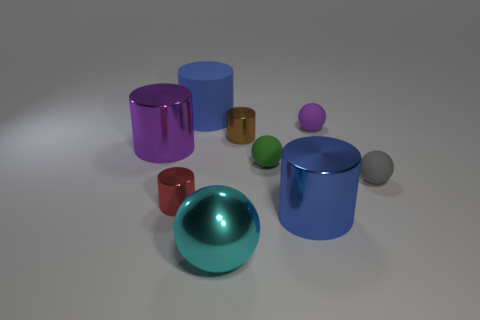Is there anything else of the same color as the big shiny ball?
Your answer should be compact. No. Is the material of the large blue thing right of the cyan thing the same as the small purple object?
Your response must be concise. No. What number of things are behind the large blue metal cylinder and right of the tiny brown object?
Ensure brevity in your answer.  3. How big is the blue cylinder that is on the right side of the blue object behind the brown object?
Provide a succinct answer. Large. Are there more metal balls than large blue cylinders?
Make the answer very short. No. There is a large object that is on the right side of the brown metallic cylinder; is its color the same as the large cylinder behind the purple metal cylinder?
Your answer should be compact. Yes. Is there a metallic thing that is on the right side of the big cyan metal sphere that is in front of the gray matte object?
Offer a very short reply. Yes. Is the number of purple metallic cylinders that are in front of the red cylinder less than the number of big blue cylinders that are behind the small purple matte thing?
Provide a short and direct response. Yes. Is the large blue cylinder in front of the big purple object made of the same material as the small cylinder in front of the big purple shiny object?
Ensure brevity in your answer.  Yes. How many small objects are purple metallic balls or objects?
Offer a very short reply. 5. 